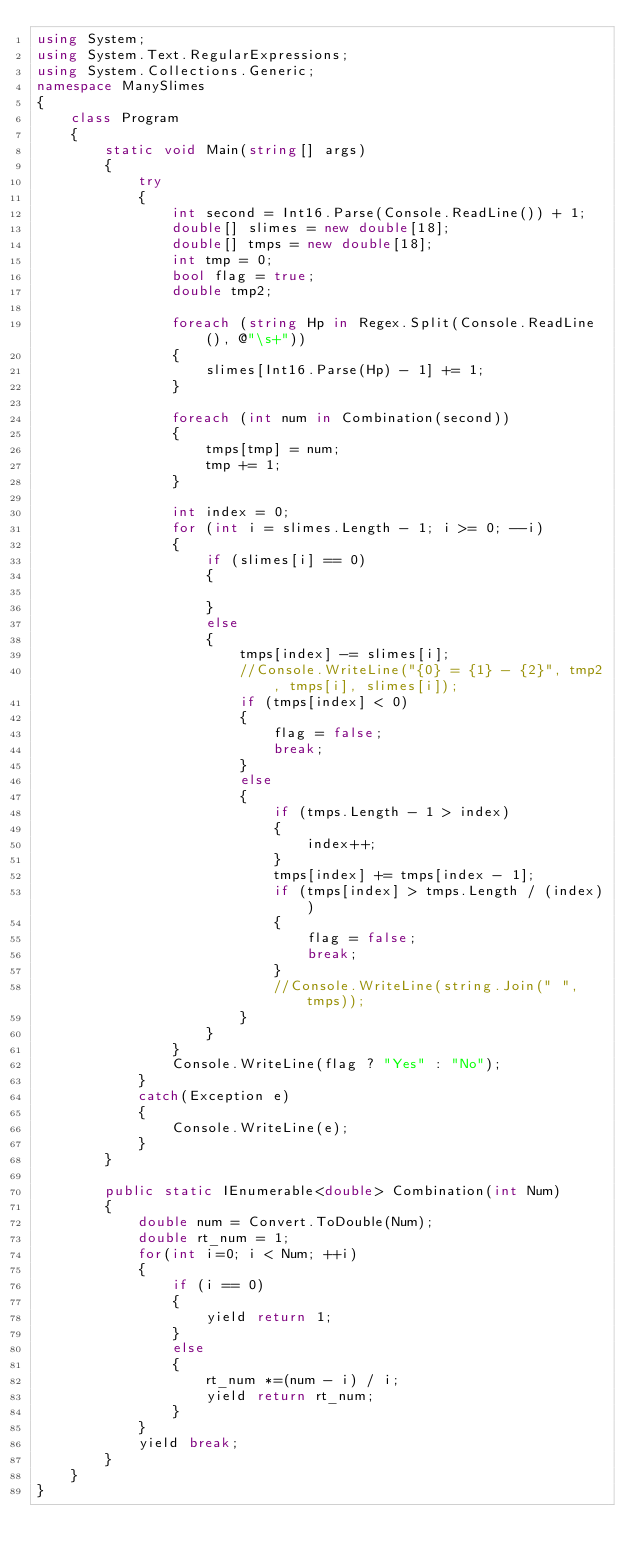Convert code to text. <code><loc_0><loc_0><loc_500><loc_500><_C#_>using System;
using System.Text.RegularExpressions;
using System.Collections.Generic;
namespace ManySlimes
{
    class Program
    {
        static void Main(string[] args)
        {
            try
            {
                int second = Int16.Parse(Console.ReadLine()) + 1;
                double[] slimes = new double[18];
                double[] tmps = new double[18];
                int tmp = 0;
                bool flag = true;
                double tmp2;

                foreach (string Hp in Regex.Split(Console.ReadLine(), @"\s+"))
                {
                    slimes[Int16.Parse(Hp) - 1] += 1;
                }

                foreach (int num in Combination(second))
                {
                    tmps[tmp] = num;
                    tmp += 1;
                }

                int index = 0;
                for (int i = slimes.Length - 1; i >= 0; --i)
                {
                    if (slimes[i] == 0)
                    {

                    }
                    else
                    {
                        tmps[index] -= slimes[i];
                        //Console.WriteLine("{0} = {1} - {2}", tmp2, tmps[i], slimes[i]);
                        if (tmps[index] < 0)
                        {
                            flag = false;
                            break;
                        }
                        else
                        {
                            if (tmps.Length - 1 > index)
                            {
                                index++;
                            }
                            tmps[index] += tmps[index - 1];
                            if (tmps[index] > tmps.Length / (index))
                            {
                                flag = false;
                                break;
                            }
                            //Console.WriteLine(string.Join(" ", tmps));
                        }
                    }
                }
                Console.WriteLine(flag ? "Yes" : "No");
            }
            catch(Exception e)
            {
                Console.WriteLine(e);
            }
        }

        public static IEnumerable<double> Combination(int Num)
        {
            double num = Convert.ToDouble(Num);
            double rt_num = 1;
            for(int i=0; i < Num; ++i)
            {
                if (i == 0)
                {
                    yield return 1;
                }
                else
                {
                    rt_num *=(num - i) / i;
                    yield return rt_num;
                }
            }
            yield break;
        }
    }
}
</code> 